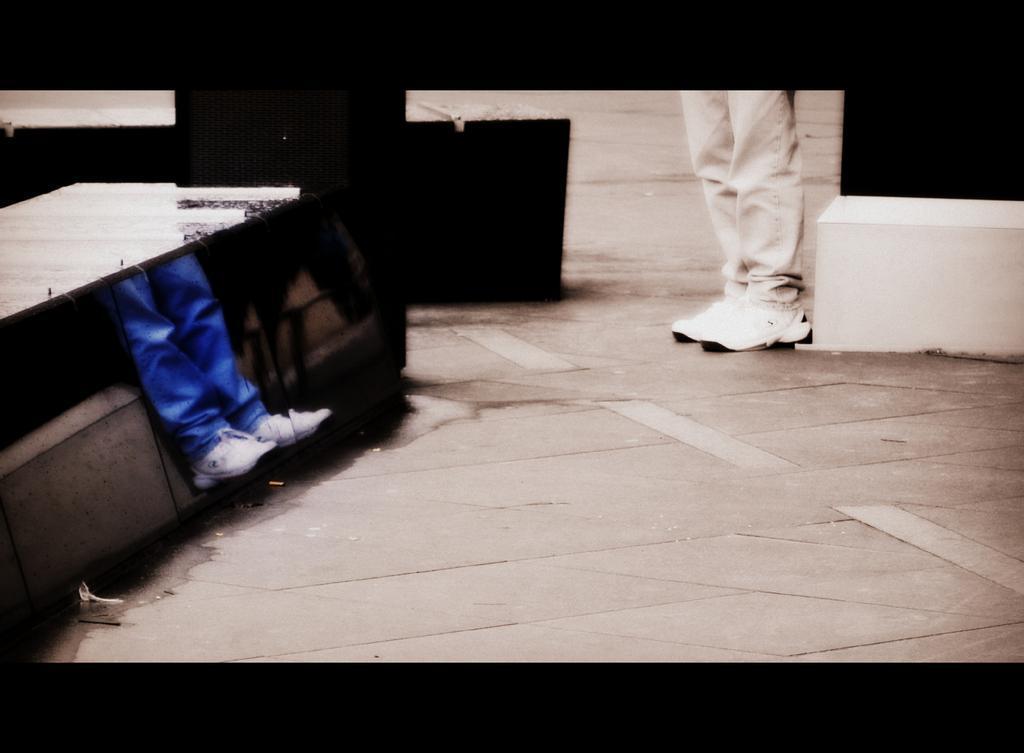In one or two sentences, can you explain what this image depicts? On the left side of the image we can see one white color object. Below the object, we can see two human legs wearing shoes. In the center of the image there is a wall, one white color solid structure, human legs and a few other objects. And we can see the black color border at the top and bottom of the image. 